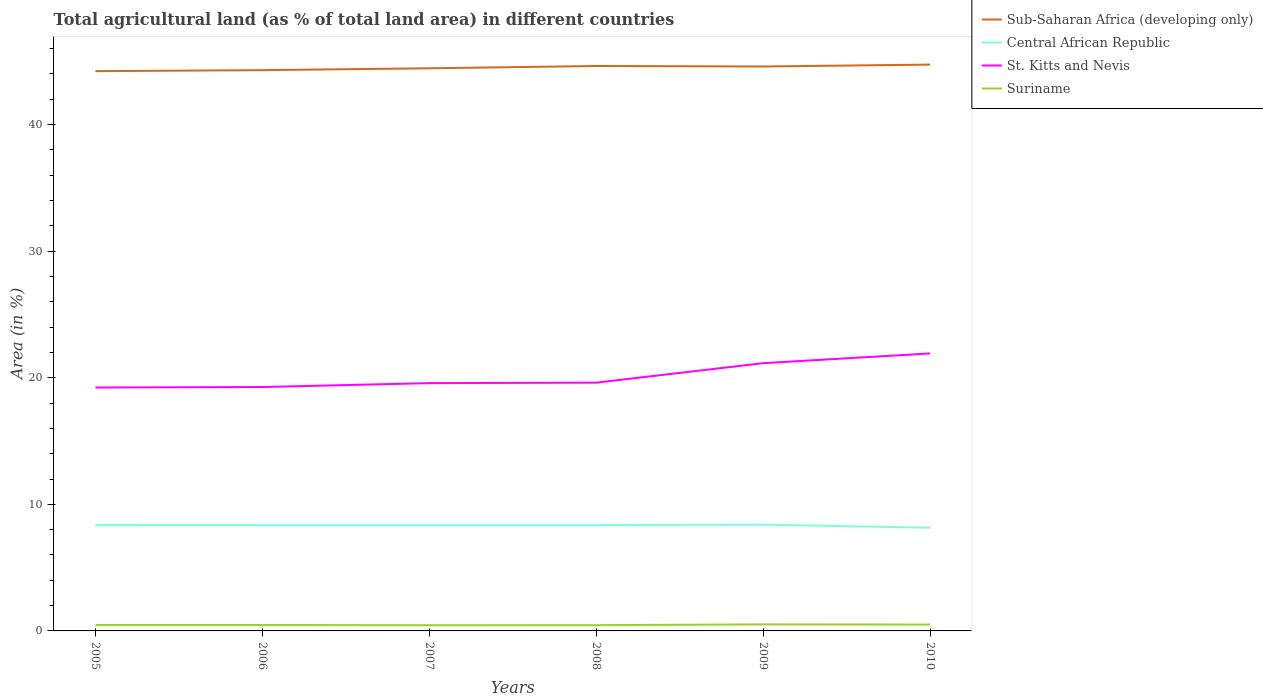Is the number of lines equal to the number of legend labels?
Provide a short and direct response. Yes. Across all years, what is the maximum percentage of agricultural land in Suriname?
Your response must be concise. 0.45. What is the total percentage of agricultural land in St. Kitts and Nevis in the graph?
Your answer should be compact. -2.31. What is the difference between the highest and the second highest percentage of agricultural land in Central African Republic?
Ensure brevity in your answer.  0.24. Is the percentage of agricultural land in Central African Republic strictly greater than the percentage of agricultural land in St. Kitts and Nevis over the years?
Ensure brevity in your answer.  Yes. How many lines are there?
Offer a terse response. 4. Does the graph contain any zero values?
Keep it short and to the point. No. Does the graph contain grids?
Keep it short and to the point. No. Where does the legend appear in the graph?
Give a very brief answer. Top right. How many legend labels are there?
Keep it short and to the point. 4. How are the legend labels stacked?
Make the answer very short. Vertical. What is the title of the graph?
Offer a very short reply. Total agricultural land (as % of total land area) in different countries. What is the label or title of the X-axis?
Your answer should be very brief. Years. What is the label or title of the Y-axis?
Provide a succinct answer. Area (in %). What is the Area (in %) in Sub-Saharan Africa (developing only) in 2005?
Give a very brief answer. 44.22. What is the Area (in %) in Central African Republic in 2005?
Your response must be concise. 8.37. What is the Area (in %) in St. Kitts and Nevis in 2005?
Your answer should be compact. 19.23. What is the Area (in %) in Suriname in 2005?
Provide a short and direct response. 0.47. What is the Area (in %) in Sub-Saharan Africa (developing only) in 2006?
Keep it short and to the point. 44.3. What is the Area (in %) of Central African Republic in 2006?
Your answer should be compact. 8.36. What is the Area (in %) of St. Kitts and Nevis in 2006?
Offer a terse response. 19.27. What is the Area (in %) in Suriname in 2006?
Your response must be concise. 0.47. What is the Area (in %) in Sub-Saharan Africa (developing only) in 2007?
Give a very brief answer. 44.45. What is the Area (in %) of Central African Republic in 2007?
Offer a terse response. 8.36. What is the Area (in %) of St. Kitts and Nevis in 2007?
Provide a short and direct response. 19.58. What is the Area (in %) in Suriname in 2007?
Make the answer very short. 0.45. What is the Area (in %) of Sub-Saharan Africa (developing only) in 2008?
Offer a terse response. 44.63. What is the Area (in %) in Central African Republic in 2008?
Offer a very short reply. 8.36. What is the Area (in %) in St. Kitts and Nevis in 2008?
Your response must be concise. 19.62. What is the Area (in %) of Suriname in 2008?
Your answer should be compact. 0.45. What is the Area (in %) in Sub-Saharan Africa (developing only) in 2009?
Offer a terse response. 44.59. What is the Area (in %) in Central African Republic in 2009?
Provide a succinct answer. 8.4. What is the Area (in %) of St. Kitts and Nevis in 2009?
Provide a succinct answer. 21.15. What is the Area (in %) of Suriname in 2009?
Make the answer very short. 0.52. What is the Area (in %) in Sub-Saharan Africa (developing only) in 2010?
Make the answer very short. 44.74. What is the Area (in %) in Central African Republic in 2010?
Provide a short and direct response. 8.15. What is the Area (in %) in St. Kitts and Nevis in 2010?
Make the answer very short. 21.92. What is the Area (in %) in Suriname in 2010?
Your answer should be very brief. 0.5. Across all years, what is the maximum Area (in %) of Sub-Saharan Africa (developing only)?
Ensure brevity in your answer.  44.74. Across all years, what is the maximum Area (in %) of Central African Republic?
Provide a short and direct response. 8.4. Across all years, what is the maximum Area (in %) of St. Kitts and Nevis?
Your answer should be very brief. 21.92. Across all years, what is the maximum Area (in %) of Suriname?
Offer a very short reply. 0.52. Across all years, what is the minimum Area (in %) in Sub-Saharan Africa (developing only)?
Make the answer very short. 44.22. Across all years, what is the minimum Area (in %) in Central African Republic?
Provide a short and direct response. 8.15. Across all years, what is the minimum Area (in %) of St. Kitts and Nevis?
Offer a very short reply. 19.23. Across all years, what is the minimum Area (in %) of Suriname?
Offer a very short reply. 0.45. What is the total Area (in %) in Sub-Saharan Africa (developing only) in the graph?
Make the answer very short. 266.95. What is the total Area (in %) of Central African Republic in the graph?
Your response must be concise. 50.01. What is the total Area (in %) in St. Kitts and Nevis in the graph?
Offer a very short reply. 120.77. What is the total Area (in %) of Suriname in the graph?
Your answer should be very brief. 2.85. What is the difference between the Area (in %) in Sub-Saharan Africa (developing only) in 2005 and that in 2006?
Offer a terse response. -0.08. What is the difference between the Area (in %) of Central African Republic in 2005 and that in 2006?
Offer a very short reply. 0.01. What is the difference between the Area (in %) of St. Kitts and Nevis in 2005 and that in 2006?
Make the answer very short. -0.04. What is the difference between the Area (in %) of Suriname in 2005 and that in 2006?
Provide a succinct answer. 0. What is the difference between the Area (in %) of Sub-Saharan Africa (developing only) in 2005 and that in 2007?
Provide a short and direct response. -0.23. What is the difference between the Area (in %) in Central African Republic in 2005 and that in 2007?
Give a very brief answer. 0.01. What is the difference between the Area (in %) in St. Kitts and Nevis in 2005 and that in 2007?
Your answer should be very brief. -0.35. What is the difference between the Area (in %) in Suriname in 2005 and that in 2007?
Keep it short and to the point. 0.02. What is the difference between the Area (in %) of Sub-Saharan Africa (developing only) in 2005 and that in 2008?
Keep it short and to the point. -0.41. What is the difference between the Area (in %) in Central African Republic in 2005 and that in 2008?
Give a very brief answer. 0.01. What is the difference between the Area (in %) of St. Kitts and Nevis in 2005 and that in 2008?
Make the answer very short. -0.38. What is the difference between the Area (in %) in Suriname in 2005 and that in 2008?
Your response must be concise. 0.01. What is the difference between the Area (in %) in Sub-Saharan Africa (developing only) in 2005 and that in 2009?
Your response must be concise. -0.37. What is the difference between the Area (in %) of Central African Republic in 2005 and that in 2009?
Keep it short and to the point. -0.02. What is the difference between the Area (in %) of St. Kitts and Nevis in 2005 and that in 2009?
Offer a terse response. -1.92. What is the difference between the Area (in %) in Suriname in 2005 and that in 2009?
Keep it short and to the point. -0.05. What is the difference between the Area (in %) of Sub-Saharan Africa (developing only) in 2005 and that in 2010?
Provide a succinct answer. -0.52. What is the difference between the Area (in %) in Central African Republic in 2005 and that in 2010?
Your answer should be very brief. 0.22. What is the difference between the Area (in %) in St. Kitts and Nevis in 2005 and that in 2010?
Your answer should be compact. -2.69. What is the difference between the Area (in %) of Suriname in 2005 and that in 2010?
Make the answer very short. -0.04. What is the difference between the Area (in %) of Sub-Saharan Africa (developing only) in 2006 and that in 2007?
Provide a short and direct response. -0.15. What is the difference between the Area (in %) in Central African Republic in 2006 and that in 2007?
Provide a short and direct response. 0. What is the difference between the Area (in %) in St. Kitts and Nevis in 2006 and that in 2007?
Provide a short and direct response. -0.31. What is the difference between the Area (in %) in Suriname in 2006 and that in 2007?
Keep it short and to the point. 0.02. What is the difference between the Area (in %) of Sub-Saharan Africa (developing only) in 2006 and that in 2008?
Keep it short and to the point. -0.33. What is the difference between the Area (in %) in St. Kitts and Nevis in 2006 and that in 2008?
Provide a succinct answer. -0.35. What is the difference between the Area (in %) of Suriname in 2006 and that in 2008?
Provide a short and direct response. 0.01. What is the difference between the Area (in %) of Sub-Saharan Africa (developing only) in 2006 and that in 2009?
Give a very brief answer. -0.29. What is the difference between the Area (in %) of Central African Republic in 2006 and that in 2009?
Your answer should be very brief. -0.03. What is the difference between the Area (in %) in St. Kitts and Nevis in 2006 and that in 2009?
Your response must be concise. -1.88. What is the difference between the Area (in %) in Suriname in 2006 and that in 2009?
Provide a succinct answer. -0.05. What is the difference between the Area (in %) of Sub-Saharan Africa (developing only) in 2006 and that in 2010?
Your answer should be compact. -0.44. What is the difference between the Area (in %) of Central African Republic in 2006 and that in 2010?
Provide a succinct answer. 0.21. What is the difference between the Area (in %) of St. Kitts and Nevis in 2006 and that in 2010?
Offer a very short reply. -2.65. What is the difference between the Area (in %) of Suriname in 2006 and that in 2010?
Keep it short and to the point. -0.04. What is the difference between the Area (in %) in Sub-Saharan Africa (developing only) in 2007 and that in 2008?
Ensure brevity in your answer.  -0.18. What is the difference between the Area (in %) of St. Kitts and Nevis in 2007 and that in 2008?
Give a very brief answer. -0.04. What is the difference between the Area (in %) of Suriname in 2007 and that in 2008?
Keep it short and to the point. -0.01. What is the difference between the Area (in %) in Sub-Saharan Africa (developing only) in 2007 and that in 2009?
Your answer should be compact. -0.14. What is the difference between the Area (in %) of Central African Republic in 2007 and that in 2009?
Give a very brief answer. -0.03. What is the difference between the Area (in %) in St. Kitts and Nevis in 2007 and that in 2009?
Offer a terse response. -1.58. What is the difference between the Area (in %) in Suriname in 2007 and that in 2009?
Keep it short and to the point. -0.07. What is the difference between the Area (in %) of Sub-Saharan Africa (developing only) in 2007 and that in 2010?
Your answer should be very brief. -0.29. What is the difference between the Area (in %) in Central African Republic in 2007 and that in 2010?
Your response must be concise. 0.21. What is the difference between the Area (in %) of St. Kitts and Nevis in 2007 and that in 2010?
Your response must be concise. -2.35. What is the difference between the Area (in %) in Suriname in 2007 and that in 2010?
Give a very brief answer. -0.05. What is the difference between the Area (in %) of Sub-Saharan Africa (developing only) in 2008 and that in 2009?
Keep it short and to the point. 0.04. What is the difference between the Area (in %) of Central African Republic in 2008 and that in 2009?
Your response must be concise. -0.03. What is the difference between the Area (in %) of St. Kitts and Nevis in 2008 and that in 2009?
Make the answer very short. -1.54. What is the difference between the Area (in %) of Suriname in 2008 and that in 2009?
Make the answer very short. -0.06. What is the difference between the Area (in %) of Sub-Saharan Africa (developing only) in 2008 and that in 2010?
Your response must be concise. -0.11. What is the difference between the Area (in %) of Central African Republic in 2008 and that in 2010?
Keep it short and to the point. 0.21. What is the difference between the Area (in %) in St. Kitts and Nevis in 2008 and that in 2010?
Offer a terse response. -2.31. What is the difference between the Area (in %) in Suriname in 2008 and that in 2010?
Offer a very short reply. -0.05. What is the difference between the Area (in %) in Sub-Saharan Africa (developing only) in 2009 and that in 2010?
Make the answer very short. -0.15. What is the difference between the Area (in %) of Central African Republic in 2009 and that in 2010?
Offer a terse response. 0.24. What is the difference between the Area (in %) in St. Kitts and Nevis in 2009 and that in 2010?
Offer a very short reply. -0.77. What is the difference between the Area (in %) in Suriname in 2009 and that in 2010?
Make the answer very short. 0.01. What is the difference between the Area (in %) of Sub-Saharan Africa (developing only) in 2005 and the Area (in %) of Central African Republic in 2006?
Offer a very short reply. 35.86. What is the difference between the Area (in %) in Sub-Saharan Africa (developing only) in 2005 and the Area (in %) in St. Kitts and Nevis in 2006?
Provide a succinct answer. 24.95. What is the difference between the Area (in %) in Sub-Saharan Africa (developing only) in 2005 and the Area (in %) in Suriname in 2006?
Ensure brevity in your answer.  43.76. What is the difference between the Area (in %) of Central African Republic in 2005 and the Area (in %) of St. Kitts and Nevis in 2006?
Ensure brevity in your answer.  -10.9. What is the difference between the Area (in %) of Central African Republic in 2005 and the Area (in %) of Suriname in 2006?
Provide a short and direct response. 7.9. What is the difference between the Area (in %) of St. Kitts and Nevis in 2005 and the Area (in %) of Suriname in 2006?
Give a very brief answer. 18.76. What is the difference between the Area (in %) of Sub-Saharan Africa (developing only) in 2005 and the Area (in %) of Central African Republic in 2007?
Offer a very short reply. 35.86. What is the difference between the Area (in %) of Sub-Saharan Africa (developing only) in 2005 and the Area (in %) of St. Kitts and Nevis in 2007?
Your answer should be compact. 24.65. What is the difference between the Area (in %) in Sub-Saharan Africa (developing only) in 2005 and the Area (in %) in Suriname in 2007?
Your answer should be very brief. 43.78. What is the difference between the Area (in %) in Central African Republic in 2005 and the Area (in %) in St. Kitts and Nevis in 2007?
Keep it short and to the point. -11.21. What is the difference between the Area (in %) in Central African Republic in 2005 and the Area (in %) in Suriname in 2007?
Give a very brief answer. 7.92. What is the difference between the Area (in %) in St. Kitts and Nevis in 2005 and the Area (in %) in Suriname in 2007?
Your response must be concise. 18.78. What is the difference between the Area (in %) of Sub-Saharan Africa (developing only) in 2005 and the Area (in %) of Central African Republic in 2008?
Your answer should be compact. 35.86. What is the difference between the Area (in %) of Sub-Saharan Africa (developing only) in 2005 and the Area (in %) of St. Kitts and Nevis in 2008?
Your answer should be very brief. 24.61. What is the difference between the Area (in %) in Sub-Saharan Africa (developing only) in 2005 and the Area (in %) in Suriname in 2008?
Offer a very short reply. 43.77. What is the difference between the Area (in %) in Central African Republic in 2005 and the Area (in %) in St. Kitts and Nevis in 2008?
Your response must be concise. -11.24. What is the difference between the Area (in %) of Central African Republic in 2005 and the Area (in %) of Suriname in 2008?
Ensure brevity in your answer.  7.92. What is the difference between the Area (in %) of St. Kitts and Nevis in 2005 and the Area (in %) of Suriname in 2008?
Make the answer very short. 18.78. What is the difference between the Area (in %) of Sub-Saharan Africa (developing only) in 2005 and the Area (in %) of Central African Republic in 2009?
Offer a very short reply. 35.83. What is the difference between the Area (in %) in Sub-Saharan Africa (developing only) in 2005 and the Area (in %) in St. Kitts and Nevis in 2009?
Your answer should be compact. 23.07. What is the difference between the Area (in %) in Sub-Saharan Africa (developing only) in 2005 and the Area (in %) in Suriname in 2009?
Ensure brevity in your answer.  43.71. What is the difference between the Area (in %) in Central African Republic in 2005 and the Area (in %) in St. Kitts and Nevis in 2009?
Provide a short and direct response. -12.78. What is the difference between the Area (in %) in Central African Republic in 2005 and the Area (in %) in Suriname in 2009?
Ensure brevity in your answer.  7.86. What is the difference between the Area (in %) in St. Kitts and Nevis in 2005 and the Area (in %) in Suriname in 2009?
Ensure brevity in your answer.  18.72. What is the difference between the Area (in %) of Sub-Saharan Africa (developing only) in 2005 and the Area (in %) of Central African Republic in 2010?
Make the answer very short. 36.07. What is the difference between the Area (in %) in Sub-Saharan Africa (developing only) in 2005 and the Area (in %) in St. Kitts and Nevis in 2010?
Ensure brevity in your answer.  22.3. What is the difference between the Area (in %) of Sub-Saharan Africa (developing only) in 2005 and the Area (in %) of Suriname in 2010?
Give a very brief answer. 43.72. What is the difference between the Area (in %) in Central African Republic in 2005 and the Area (in %) in St. Kitts and Nevis in 2010?
Provide a succinct answer. -13.55. What is the difference between the Area (in %) in Central African Republic in 2005 and the Area (in %) in Suriname in 2010?
Give a very brief answer. 7.87. What is the difference between the Area (in %) of St. Kitts and Nevis in 2005 and the Area (in %) of Suriname in 2010?
Your response must be concise. 18.73. What is the difference between the Area (in %) of Sub-Saharan Africa (developing only) in 2006 and the Area (in %) of Central African Republic in 2007?
Offer a terse response. 35.94. What is the difference between the Area (in %) of Sub-Saharan Africa (developing only) in 2006 and the Area (in %) of St. Kitts and Nevis in 2007?
Keep it short and to the point. 24.73. What is the difference between the Area (in %) in Sub-Saharan Africa (developing only) in 2006 and the Area (in %) in Suriname in 2007?
Make the answer very short. 43.86. What is the difference between the Area (in %) of Central African Republic in 2006 and the Area (in %) of St. Kitts and Nevis in 2007?
Your answer should be very brief. -11.21. What is the difference between the Area (in %) of Central African Republic in 2006 and the Area (in %) of Suriname in 2007?
Your answer should be very brief. 7.91. What is the difference between the Area (in %) in St. Kitts and Nevis in 2006 and the Area (in %) in Suriname in 2007?
Provide a short and direct response. 18.82. What is the difference between the Area (in %) of Sub-Saharan Africa (developing only) in 2006 and the Area (in %) of Central African Republic in 2008?
Provide a short and direct response. 35.94. What is the difference between the Area (in %) in Sub-Saharan Africa (developing only) in 2006 and the Area (in %) in St. Kitts and Nevis in 2008?
Offer a terse response. 24.69. What is the difference between the Area (in %) in Sub-Saharan Africa (developing only) in 2006 and the Area (in %) in Suriname in 2008?
Keep it short and to the point. 43.85. What is the difference between the Area (in %) in Central African Republic in 2006 and the Area (in %) in St. Kitts and Nevis in 2008?
Ensure brevity in your answer.  -11.25. What is the difference between the Area (in %) of Central African Republic in 2006 and the Area (in %) of Suriname in 2008?
Make the answer very short. 7.91. What is the difference between the Area (in %) in St. Kitts and Nevis in 2006 and the Area (in %) in Suriname in 2008?
Your answer should be compact. 18.82. What is the difference between the Area (in %) of Sub-Saharan Africa (developing only) in 2006 and the Area (in %) of Central African Republic in 2009?
Your answer should be very brief. 35.91. What is the difference between the Area (in %) in Sub-Saharan Africa (developing only) in 2006 and the Area (in %) in St. Kitts and Nevis in 2009?
Offer a very short reply. 23.15. What is the difference between the Area (in %) of Sub-Saharan Africa (developing only) in 2006 and the Area (in %) of Suriname in 2009?
Offer a terse response. 43.79. What is the difference between the Area (in %) of Central African Republic in 2006 and the Area (in %) of St. Kitts and Nevis in 2009?
Your answer should be compact. -12.79. What is the difference between the Area (in %) of Central African Republic in 2006 and the Area (in %) of Suriname in 2009?
Ensure brevity in your answer.  7.85. What is the difference between the Area (in %) in St. Kitts and Nevis in 2006 and the Area (in %) in Suriname in 2009?
Provide a succinct answer. 18.75. What is the difference between the Area (in %) of Sub-Saharan Africa (developing only) in 2006 and the Area (in %) of Central African Republic in 2010?
Keep it short and to the point. 36.15. What is the difference between the Area (in %) in Sub-Saharan Africa (developing only) in 2006 and the Area (in %) in St. Kitts and Nevis in 2010?
Your response must be concise. 22.38. What is the difference between the Area (in %) of Sub-Saharan Africa (developing only) in 2006 and the Area (in %) of Suriname in 2010?
Ensure brevity in your answer.  43.8. What is the difference between the Area (in %) of Central African Republic in 2006 and the Area (in %) of St. Kitts and Nevis in 2010?
Your response must be concise. -13.56. What is the difference between the Area (in %) of Central African Republic in 2006 and the Area (in %) of Suriname in 2010?
Keep it short and to the point. 7.86. What is the difference between the Area (in %) of St. Kitts and Nevis in 2006 and the Area (in %) of Suriname in 2010?
Your response must be concise. 18.77. What is the difference between the Area (in %) of Sub-Saharan Africa (developing only) in 2007 and the Area (in %) of Central African Republic in 2008?
Offer a terse response. 36.09. What is the difference between the Area (in %) of Sub-Saharan Africa (developing only) in 2007 and the Area (in %) of St. Kitts and Nevis in 2008?
Give a very brief answer. 24.84. What is the difference between the Area (in %) of Sub-Saharan Africa (developing only) in 2007 and the Area (in %) of Suriname in 2008?
Ensure brevity in your answer.  44. What is the difference between the Area (in %) of Central African Republic in 2007 and the Area (in %) of St. Kitts and Nevis in 2008?
Keep it short and to the point. -11.25. What is the difference between the Area (in %) in Central African Republic in 2007 and the Area (in %) in Suriname in 2008?
Provide a short and direct response. 7.91. What is the difference between the Area (in %) of St. Kitts and Nevis in 2007 and the Area (in %) of Suriname in 2008?
Give a very brief answer. 19.12. What is the difference between the Area (in %) in Sub-Saharan Africa (developing only) in 2007 and the Area (in %) in Central African Republic in 2009?
Ensure brevity in your answer.  36.06. What is the difference between the Area (in %) in Sub-Saharan Africa (developing only) in 2007 and the Area (in %) in St. Kitts and Nevis in 2009?
Provide a succinct answer. 23.3. What is the difference between the Area (in %) of Sub-Saharan Africa (developing only) in 2007 and the Area (in %) of Suriname in 2009?
Make the answer very short. 43.94. What is the difference between the Area (in %) in Central African Republic in 2007 and the Area (in %) in St. Kitts and Nevis in 2009?
Keep it short and to the point. -12.79. What is the difference between the Area (in %) in Central African Republic in 2007 and the Area (in %) in Suriname in 2009?
Offer a terse response. 7.85. What is the difference between the Area (in %) of St. Kitts and Nevis in 2007 and the Area (in %) of Suriname in 2009?
Your response must be concise. 19.06. What is the difference between the Area (in %) of Sub-Saharan Africa (developing only) in 2007 and the Area (in %) of Central African Republic in 2010?
Your answer should be very brief. 36.3. What is the difference between the Area (in %) in Sub-Saharan Africa (developing only) in 2007 and the Area (in %) in St. Kitts and Nevis in 2010?
Your response must be concise. 22.53. What is the difference between the Area (in %) of Sub-Saharan Africa (developing only) in 2007 and the Area (in %) of Suriname in 2010?
Make the answer very short. 43.95. What is the difference between the Area (in %) in Central African Republic in 2007 and the Area (in %) in St. Kitts and Nevis in 2010?
Provide a succinct answer. -13.56. What is the difference between the Area (in %) of Central African Republic in 2007 and the Area (in %) of Suriname in 2010?
Your answer should be compact. 7.86. What is the difference between the Area (in %) in St. Kitts and Nevis in 2007 and the Area (in %) in Suriname in 2010?
Provide a succinct answer. 19.07. What is the difference between the Area (in %) in Sub-Saharan Africa (developing only) in 2008 and the Area (in %) in Central African Republic in 2009?
Keep it short and to the point. 36.24. What is the difference between the Area (in %) in Sub-Saharan Africa (developing only) in 2008 and the Area (in %) in St. Kitts and Nevis in 2009?
Your answer should be very brief. 23.48. What is the difference between the Area (in %) in Sub-Saharan Africa (developing only) in 2008 and the Area (in %) in Suriname in 2009?
Offer a very short reply. 44.12. What is the difference between the Area (in %) in Central African Republic in 2008 and the Area (in %) in St. Kitts and Nevis in 2009?
Provide a succinct answer. -12.79. What is the difference between the Area (in %) in Central African Republic in 2008 and the Area (in %) in Suriname in 2009?
Provide a short and direct response. 7.85. What is the difference between the Area (in %) in St. Kitts and Nevis in 2008 and the Area (in %) in Suriname in 2009?
Provide a succinct answer. 19.1. What is the difference between the Area (in %) in Sub-Saharan Africa (developing only) in 2008 and the Area (in %) in Central African Republic in 2010?
Your answer should be compact. 36.48. What is the difference between the Area (in %) in Sub-Saharan Africa (developing only) in 2008 and the Area (in %) in St. Kitts and Nevis in 2010?
Provide a succinct answer. 22.71. What is the difference between the Area (in %) of Sub-Saharan Africa (developing only) in 2008 and the Area (in %) of Suriname in 2010?
Your response must be concise. 44.13. What is the difference between the Area (in %) in Central African Republic in 2008 and the Area (in %) in St. Kitts and Nevis in 2010?
Ensure brevity in your answer.  -13.56. What is the difference between the Area (in %) in Central African Republic in 2008 and the Area (in %) in Suriname in 2010?
Offer a very short reply. 7.86. What is the difference between the Area (in %) of St. Kitts and Nevis in 2008 and the Area (in %) of Suriname in 2010?
Your answer should be very brief. 19.11. What is the difference between the Area (in %) in Sub-Saharan Africa (developing only) in 2009 and the Area (in %) in Central African Republic in 2010?
Offer a terse response. 36.44. What is the difference between the Area (in %) of Sub-Saharan Africa (developing only) in 2009 and the Area (in %) of St. Kitts and Nevis in 2010?
Offer a very short reply. 22.67. What is the difference between the Area (in %) in Sub-Saharan Africa (developing only) in 2009 and the Area (in %) in Suriname in 2010?
Give a very brief answer. 44.09. What is the difference between the Area (in %) of Central African Republic in 2009 and the Area (in %) of St. Kitts and Nevis in 2010?
Provide a short and direct response. -13.53. What is the difference between the Area (in %) in Central African Republic in 2009 and the Area (in %) in Suriname in 2010?
Your response must be concise. 7.89. What is the difference between the Area (in %) in St. Kitts and Nevis in 2009 and the Area (in %) in Suriname in 2010?
Give a very brief answer. 20.65. What is the average Area (in %) in Sub-Saharan Africa (developing only) per year?
Your answer should be compact. 44.49. What is the average Area (in %) of Central African Republic per year?
Your answer should be very brief. 8.33. What is the average Area (in %) of St. Kitts and Nevis per year?
Give a very brief answer. 20.13. What is the average Area (in %) of Suriname per year?
Ensure brevity in your answer.  0.48. In the year 2005, what is the difference between the Area (in %) of Sub-Saharan Africa (developing only) and Area (in %) of Central African Republic?
Provide a succinct answer. 35.85. In the year 2005, what is the difference between the Area (in %) of Sub-Saharan Africa (developing only) and Area (in %) of St. Kitts and Nevis?
Provide a short and direct response. 24.99. In the year 2005, what is the difference between the Area (in %) in Sub-Saharan Africa (developing only) and Area (in %) in Suriname?
Offer a terse response. 43.76. In the year 2005, what is the difference between the Area (in %) in Central African Republic and Area (in %) in St. Kitts and Nevis?
Give a very brief answer. -10.86. In the year 2005, what is the difference between the Area (in %) in Central African Republic and Area (in %) in Suriname?
Your response must be concise. 7.9. In the year 2005, what is the difference between the Area (in %) in St. Kitts and Nevis and Area (in %) in Suriname?
Keep it short and to the point. 18.76. In the year 2006, what is the difference between the Area (in %) of Sub-Saharan Africa (developing only) and Area (in %) of Central African Republic?
Your response must be concise. 35.94. In the year 2006, what is the difference between the Area (in %) in Sub-Saharan Africa (developing only) and Area (in %) in St. Kitts and Nevis?
Provide a succinct answer. 25.04. In the year 2006, what is the difference between the Area (in %) of Sub-Saharan Africa (developing only) and Area (in %) of Suriname?
Keep it short and to the point. 43.84. In the year 2006, what is the difference between the Area (in %) of Central African Republic and Area (in %) of St. Kitts and Nevis?
Make the answer very short. -10.91. In the year 2006, what is the difference between the Area (in %) in Central African Republic and Area (in %) in Suriname?
Make the answer very short. 7.9. In the year 2006, what is the difference between the Area (in %) of St. Kitts and Nevis and Area (in %) of Suriname?
Offer a very short reply. 18.8. In the year 2007, what is the difference between the Area (in %) of Sub-Saharan Africa (developing only) and Area (in %) of Central African Republic?
Offer a very short reply. 36.09. In the year 2007, what is the difference between the Area (in %) in Sub-Saharan Africa (developing only) and Area (in %) in St. Kitts and Nevis?
Make the answer very short. 24.87. In the year 2007, what is the difference between the Area (in %) in Sub-Saharan Africa (developing only) and Area (in %) in Suriname?
Provide a short and direct response. 44. In the year 2007, what is the difference between the Area (in %) in Central African Republic and Area (in %) in St. Kitts and Nevis?
Provide a short and direct response. -11.21. In the year 2007, what is the difference between the Area (in %) of Central African Republic and Area (in %) of Suriname?
Provide a short and direct response. 7.91. In the year 2007, what is the difference between the Area (in %) in St. Kitts and Nevis and Area (in %) in Suriname?
Keep it short and to the point. 19.13. In the year 2008, what is the difference between the Area (in %) in Sub-Saharan Africa (developing only) and Area (in %) in Central African Republic?
Your answer should be compact. 36.27. In the year 2008, what is the difference between the Area (in %) in Sub-Saharan Africa (developing only) and Area (in %) in St. Kitts and Nevis?
Offer a terse response. 25.02. In the year 2008, what is the difference between the Area (in %) in Sub-Saharan Africa (developing only) and Area (in %) in Suriname?
Ensure brevity in your answer.  44.18. In the year 2008, what is the difference between the Area (in %) of Central African Republic and Area (in %) of St. Kitts and Nevis?
Your response must be concise. -11.25. In the year 2008, what is the difference between the Area (in %) of Central African Republic and Area (in %) of Suriname?
Ensure brevity in your answer.  7.91. In the year 2008, what is the difference between the Area (in %) in St. Kitts and Nevis and Area (in %) in Suriname?
Offer a very short reply. 19.16. In the year 2009, what is the difference between the Area (in %) of Sub-Saharan Africa (developing only) and Area (in %) of Central African Republic?
Offer a very short reply. 36.2. In the year 2009, what is the difference between the Area (in %) of Sub-Saharan Africa (developing only) and Area (in %) of St. Kitts and Nevis?
Ensure brevity in your answer.  23.44. In the year 2009, what is the difference between the Area (in %) of Sub-Saharan Africa (developing only) and Area (in %) of Suriname?
Provide a succinct answer. 44.08. In the year 2009, what is the difference between the Area (in %) in Central African Republic and Area (in %) in St. Kitts and Nevis?
Offer a very short reply. -12.76. In the year 2009, what is the difference between the Area (in %) of Central African Republic and Area (in %) of Suriname?
Your answer should be very brief. 7.88. In the year 2009, what is the difference between the Area (in %) of St. Kitts and Nevis and Area (in %) of Suriname?
Provide a succinct answer. 20.64. In the year 2010, what is the difference between the Area (in %) of Sub-Saharan Africa (developing only) and Area (in %) of Central African Republic?
Ensure brevity in your answer.  36.59. In the year 2010, what is the difference between the Area (in %) of Sub-Saharan Africa (developing only) and Area (in %) of St. Kitts and Nevis?
Your response must be concise. 22.82. In the year 2010, what is the difference between the Area (in %) of Sub-Saharan Africa (developing only) and Area (in %) of Suriname?
Ensure brevity in your answer.  44.24. In the year 2010, what is the difference between the Area (in %) in Central African Republic and Area (in %) in St. Kitts and Nevis?
Offer a very short reply. -13.77. In the year 2010, what is the difference between the Area (in %) in Central African Republic and Area (in %) in Suriname?
Keep it short and to the point. 7.65. In the year 2010, what is the difference between the Area (in %) in St. Kitts and Nevis and Area (in %) in Suriname?
Make the answer very short. 21.42. What is the ratio of the Area (in %) of Central African Republic in 2005 to that in 2006?
Your answer should be compact. 1. What is the ratio of the Area (in %) of St. Kitts and Nevis in 2005 to that in 2006?
Ensure brevity in your answer.  1. What is the ratio of the Area (in %) in Central African Republic in 2005 to that in 2007?
Provide a succinct answer. 1. What is the ratio of the Area (in %) of St. Kitts and Nevis in 2005 to that in 2007?
Your response must be concise. 0.98. What is the ratio of the Area (in %) of Sub-Saharan Africa (developing only) in 2005 to that in 2008?
Offer a very short reply. 0.99. What is the ratio of the Area (in %) in St. Kitts and Nevis in 2005 to that in 2008?
Ensure brevity in your answer.  0.98. What is the ratio of the Area (in %) of Suriname in 2005 to that in 2008?
Give a very brief answer. 1.03. What is the ratio of the Area (in %) in Central African Republic in 2005 to that in 2009?
Keep it short and to the point. 1. What is the ratio of the Area (in %) of St. Kitts and Nevis in 2005 to that in 2009?
Provide a succinct answer. 0.91. What is the ratio of the Area (in %) in Suriname in 2005 to that in 2009?
Ensure brevity in your answer.  0.91. What is the ratio of the Area (in %) of Sub-Saharan Africa (developing only) in 2005 to that in 2010?
Offer a terse response. 0.99. What is the ratio of the Area (in %) in Central African Republic in 2005 to that in 2010?
Offer a terse response. 1.03. What is the ratio of the Area (in %) in St. Kitts and Nevis in 2005 to that in 2010?
Offer a very short reply. 0.88. What is the ratio of the Area (in %) of Suriname in 2005 to that in 2010?
Give a very brief answer. 0.93. What is the ratio of the Area (in %) in St. Kitts and Nevis in 2006 to that in 2007?
Keep it short and to the point. 0.98. What is the ratio of the Area (in %) of Sub-Saharan Africa (developing only) in 2006 to that in 2008?
Provide a short and direct response. 0.99. What is the ratio of the Area (in %) of Central African Republic in 2006 to that in 2008?
Offer a terse response. 1. What is the ratio of the Area (in %) in St. Kitts and Nevis in 2006 to that in 2008?
Your response must be concise. 0.98. What is the ratio of the Area (in %) of Suriname in 2006 to that in 2008?
Your answer should be compact. 1.03. What is the ratio of the Area (in %) in Sub-Saharan Africa (developing only) in 2006 to that in 2009?
Make the answer very short. 0.99. What is the ratio of the Area (in %) of St. Kitts and Nevis in 2006 to that in 2009?
Your answer should be very brief. 0.91. What is the ratio of the Area (in %) of Suriname in 2006 to that in 2009?
Offer a very short reply. 0.91. What is the ratio of the Area (in %) of Sub-Saharan Africa (developing only) in 2006 to that in 2010?
Offer a terse response. 0.99. What is the ratio of the Area (in %) of Central African Republic in 2006 to that in 2010?
Keep it short and to the point. 1.03. What is the ratio of the Area (in %) of St. Kitts and Nevis in 2006 to that in 2010?
Keep it short and to the point. 0.88. What is the ratio of the Area (in %) of Suriname in 2006 to that in 2010?
Ensure brevity in your answer.  0.93. What is the ratio of the Area (in %) of Sub-Saharan Africa (developing only) in 2007 to that in 2008?
Give a very brief answer. 1. What is the ratio of the Area (in %) of Suriname in 2007 to that in 2008?
Ensure brevity in your answer.  0.99. What is the ratio of the Area (in %) in Central African Republic in 2007 to that in 2009?
Offer a terse response. 1. What is the ratio of the Area (in %) in St. Kitts and Nevis in 2007 to that in 2009?
Provide a short and direct response. 0.93. What is the ratio of the Area (in %) in Suriname in 2007 to that in 2009?
Provide a succinct answer. 0.87. What is the ratio of the Area (in %) of Central African Republic in 2007 to that in 2010?
Ensure brevity in your answer.  1.03. What is the ratio of the Area (in %) of St. Kitts and Nevis in 2007 to that in 2010?
Give a very brief answer. 0.89. What is the ratio of the Area (in %) of Suriname in 2007 to that in 2010?
Give a very brief answer. 0.89. What is the ratio of the Area (in %) in Central African Republic in 2008 to that in 2009?
Provide a succinct answer. 1. What is the ratio of the Area (in %) in St. Kitts and Nevis in 2008 to that in 2009?
Your response must be concise. 0.93. What is the ratio of the Area (in %) of Suriname in 2008 to that in 2009?
Give a very brief answer. 0.88. What is the ratio of the Area (in %) of Central African Republic in 2008 to that in 2010?
Your answer should be compact. 1.03. What is the ratio of the Area (in %) in St. Kitts and Nevis in 2008 to that in 2010?
Provide a succinct answer. 0.89. What is the ratio of the Area (in %) of Suriname in 2008 to that in 2010?
Provide a succinct answer. 0.9. What is the ratio of the Area (in %) in Sub-Saharan Africa (developing only) in 2009 to that in 2010?
Offer a terse response. 1. What is the ratio of the Area (in %) in Central African Republic in 2009 to that in 2010?
Offer a very short reply. 1.03. What is the ratio of the Area (in %) of St. Kitts and Nevis in 2009 to that in 2010?
Keep it short and to the point. 0.96. What is the ratio of the Area (in %) in Suriname in 2009 to that in 2010?
Provide a short and direct response. 1.03. What is the difference between the highest and the second highest Area (in %) of Sub-Saharan Africa (developing only)?
Give a very brief answer. 0.11. What is the difference between the highest and the second highest Area (in %) in Central African Republic?
Ensure brevity in your answer.  0.02. What is the difference between the highest and the second highest Area (in %) of St. Kitts and Nevis?
Your response must be concise. 0.77. What is the difference between the highest and the second highest Area (in %) of Suriname?
Provide a short and direct response. 0.01. What is the difference between the highest and the lowest Area (in %) of Sub-Saharan Africa (developing only)?
Give a very brief answer. 0.52. What is the difference between the highest and the lowest Area (in %) of Central African Republic?
Keep it short and to the point. 0.24. What is the difference between the highest and the lowest Area (in %) of St. Kitts and Nevis?
Give a very brief answer. 2.69. What is the difference between the highest and the lowest Area (in %) of Suriname?
Provide a succinct answer. 0.07. 